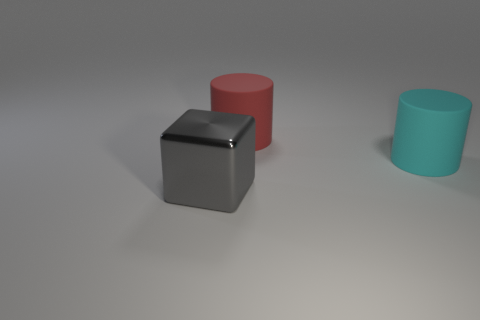Do the large matte object that is right of the large red thing and the large matte object behind the large cyan cylinder have the same shape?
Ensure brevity in your answer.  Yes. There is a metal thing; is its size the same as the rubber thing that is behind the cyan matte cylinder?
Give a very brief answer. Yes. Is the number of big objects greater than the number of big brown metal spheres?
Your answer should be very brief. Yes. Is the object that is right of the red rubber cylinder made of the same material as the big thing to the left of the red cylinder?
Offer a terse response. No. What is the material of the large gray thing?
Provide a short and direct response. Metal. Is the number of red things in front of the red matte cylinder greater than the number of large metallic blocks?
Offer a very short reply. No. How many big red matte objects are in front of the big cylinder that is in front of the cylinder that is behind the cyan object?
Make the answer very short. 0. There is a big object that is both behind the big gray metallic object and on the left side of the big cyan matte object; what is its material?
Give a very brief answer. Rubber. The large metallic thing is what color?
Provide a short and direct response. Gray. Is the number of red cylinders that are behind the cyan rubber thing greater than the number of gray metallic cubes that are in front of the big gray metal thing?
Give a very brief answer. Yes. 